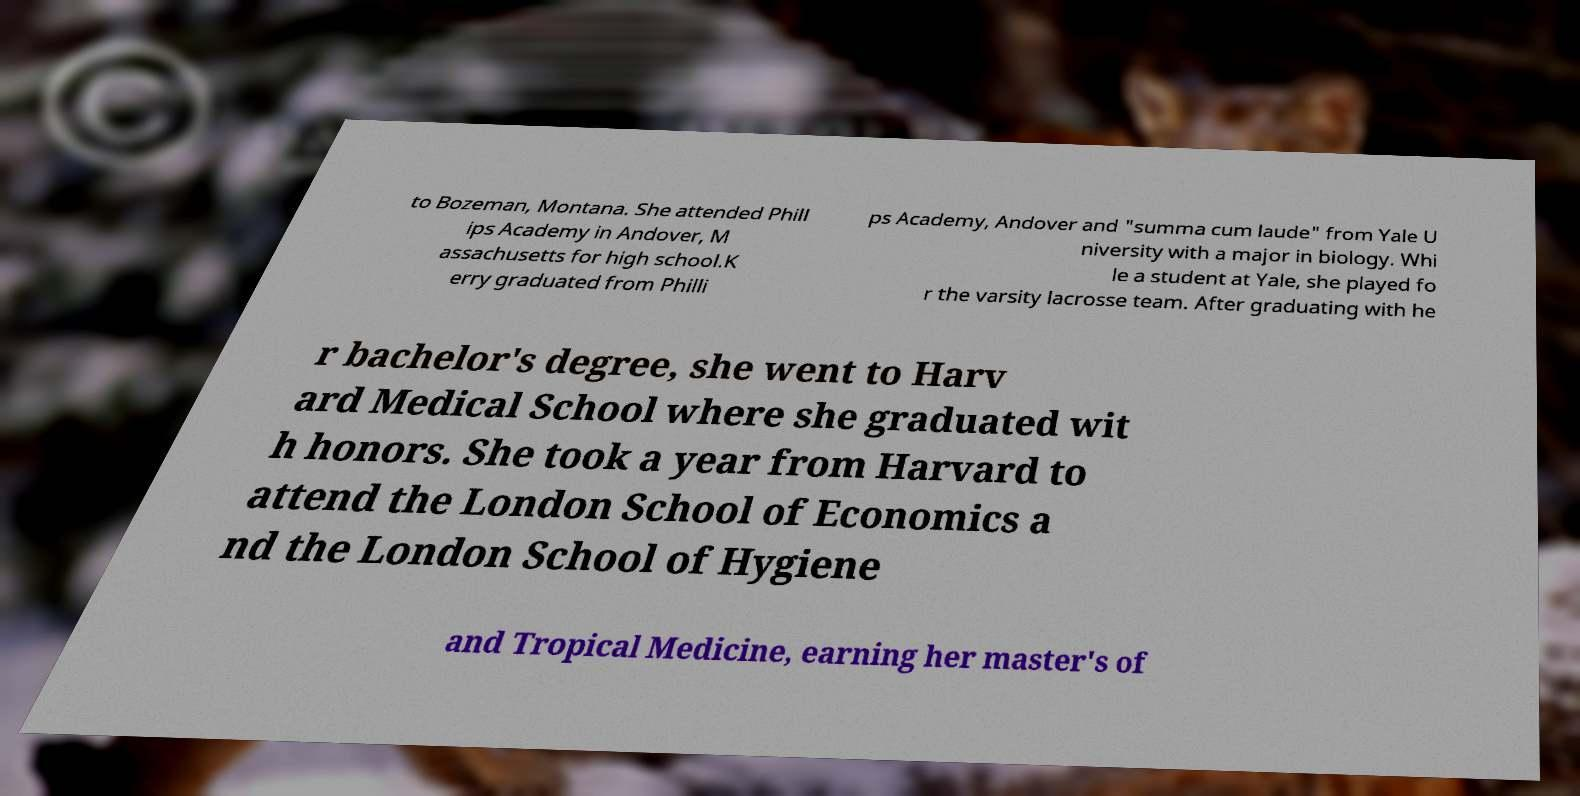Can you accurately transcribe the text from the provided image for me? to Bozeman, Montana. She attended Phill ips Academy in Andover, M assachusetts for high school.K erry graduated from Philli ps Academy, Andover and "summa cum laude" from Yale U niversity with a major in biology. Whi le a student at Yale, she played fo r the varsity lacrosse team. After graduating with he r bachelor's degree, she went to Harv ard Medical School where she graduated wit h honors. She took a year from Harvard to attend the London School of Economics a nd the London School of Hygiene and Tropical Medicine, earning her master's of 